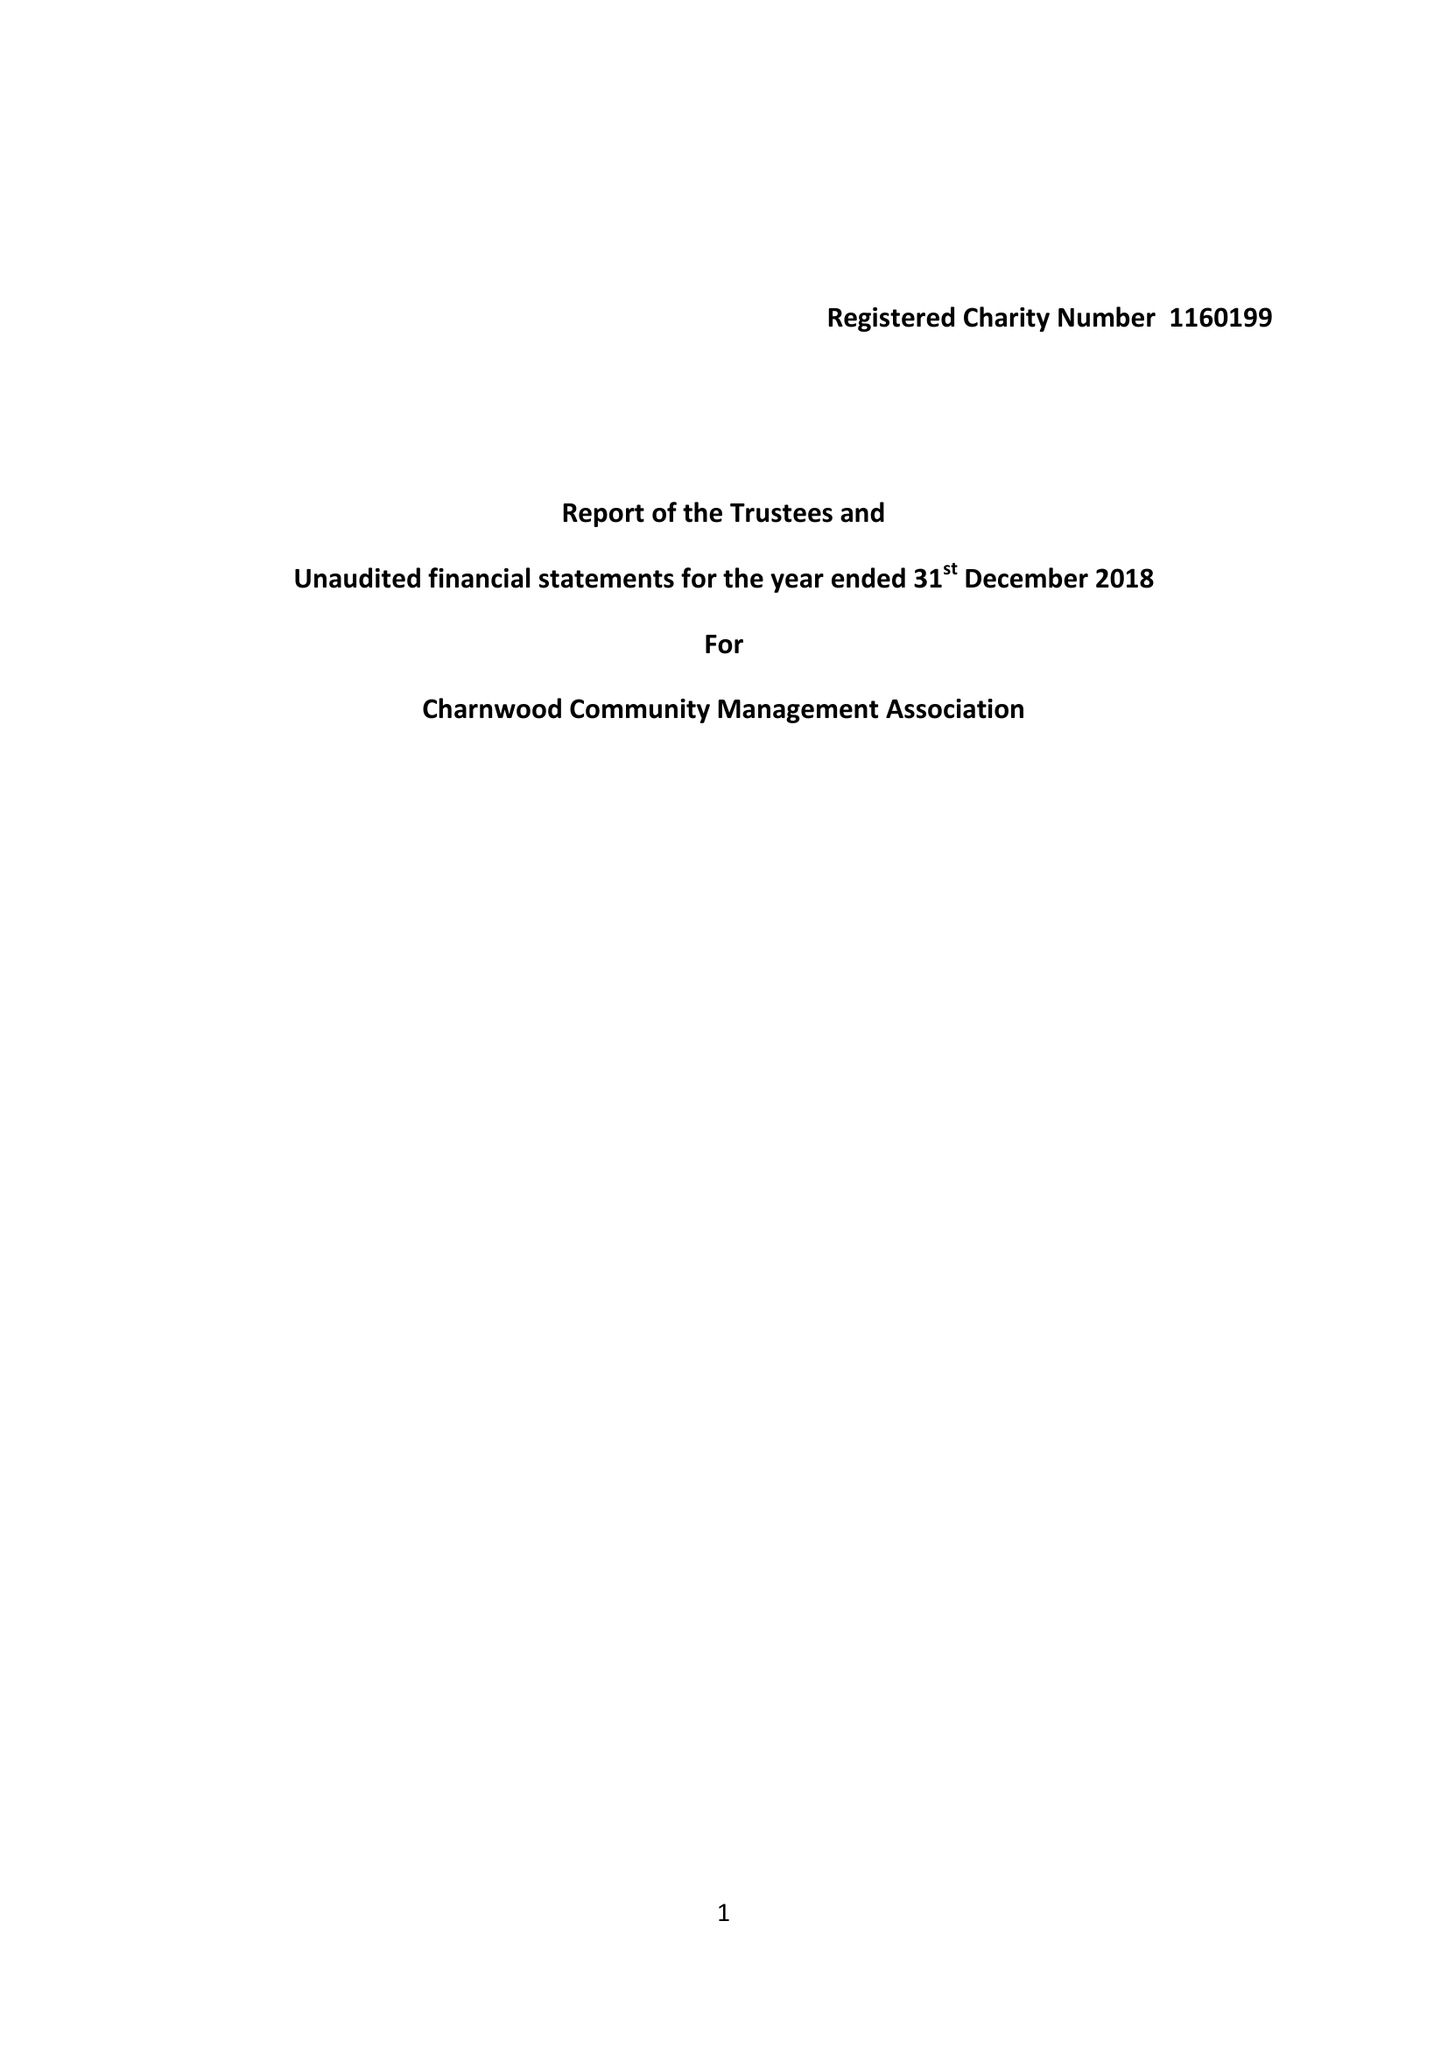What is the value for the charity_number?
Answer the question using a single word or phrase. 1160199 